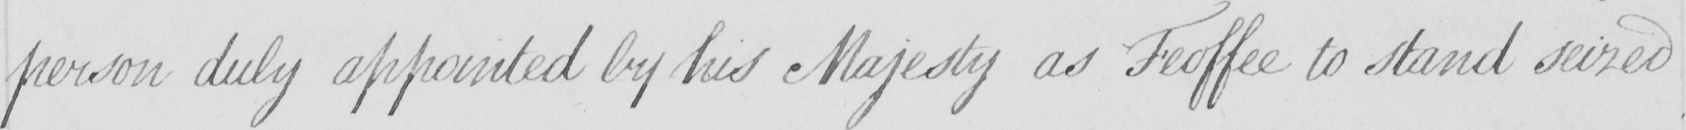Can you tell me what this handwritten text says? person duly appointed by his Majesty as Feoffee to stand seized 